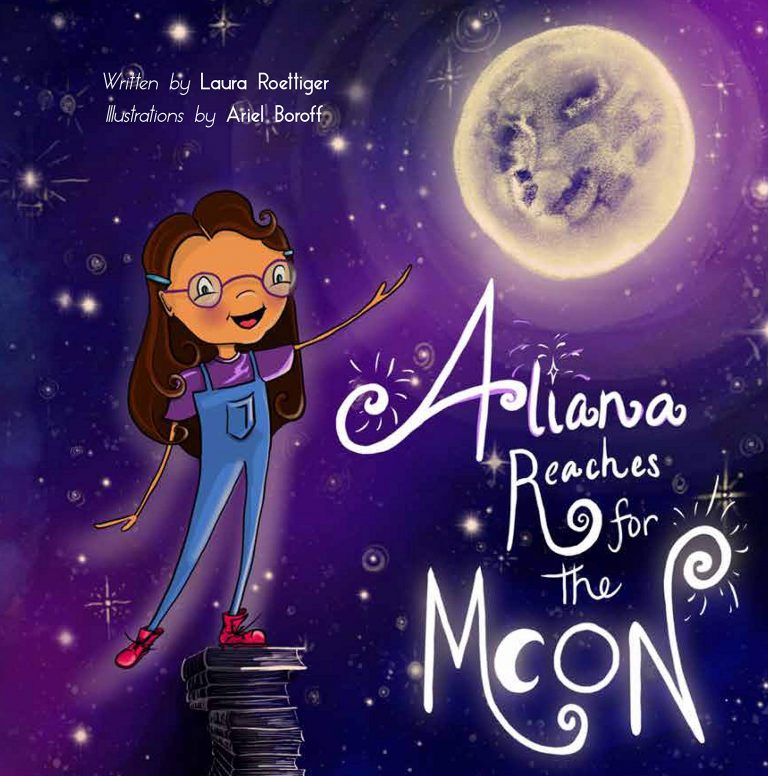Why do you think the moon is portrayed with a face in this illustration? The moon's face in the illustration adds a personal and approachable element to this celestial body, often considered distant and mysterious. By giving the moon a friendly face, the artist makes it less of an abstract concept and more of a character within the story. This anthropomorphism can symbolize that dreams and goals, while grand, are within reach and can be 'friendly' pursuits rather than daunting challenges. It suggests a universe that is interactive and reciprocal, where aspirations are not just personal ambitions but part of a broader cosmic dialogue. 